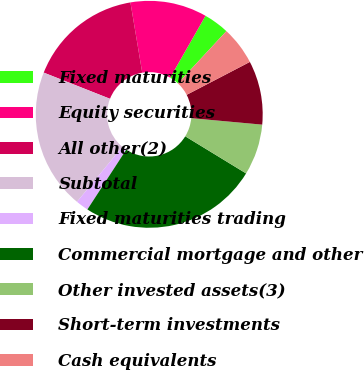<chart> <loc_0><loc_0><loc_500><loc_500><pie_chart><fcel>Fixed maturities<fcel>Equity securities<fcel>All other(2)<fcel>Subtotal<fcel>Fixed maturities trading<fcel>Commercial mortgage and other<fcel>Other invested assets(3)<fcel>Short-term investments<fcel>Cash equivalents<nl><fcel>3.64%<fcel>10.91%<fcel>16.36%<fcel>20.0%<fcel>1.82%<fcel>25.45%<fcel>7.27%<fcel>9.09%<fcel>5.46%<nl></chart> 